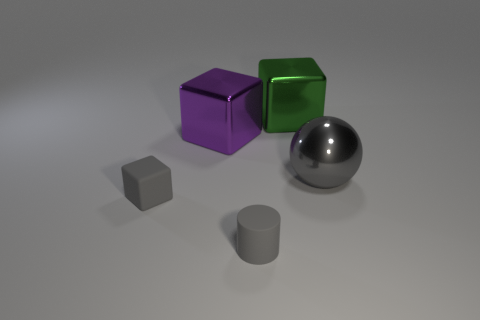Add 1 purple metallic spheres. How many objects exist? 6 Subtract all spheres. How many objects are left? 4 Subtract 0 cyan cylinders. How many objects are left? 5 Subtract all small objects. Subtract all big metallic spheres. How many objects are left? 2 Add 4 large gray spheres. How many large gray spheres are left? 5 Add 4 gray objects. How many gray objects exist? 7 